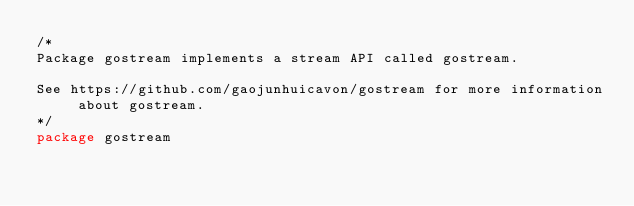Convert code to text. <code><loc_0><loc_0><loc_500><loc_500><_Go_>/*
Package gostream implements a stream API called gostream.

See https://github.com/gaojunhuicavon/gostream for more information about gostream.
*/
package gostream
</code> 